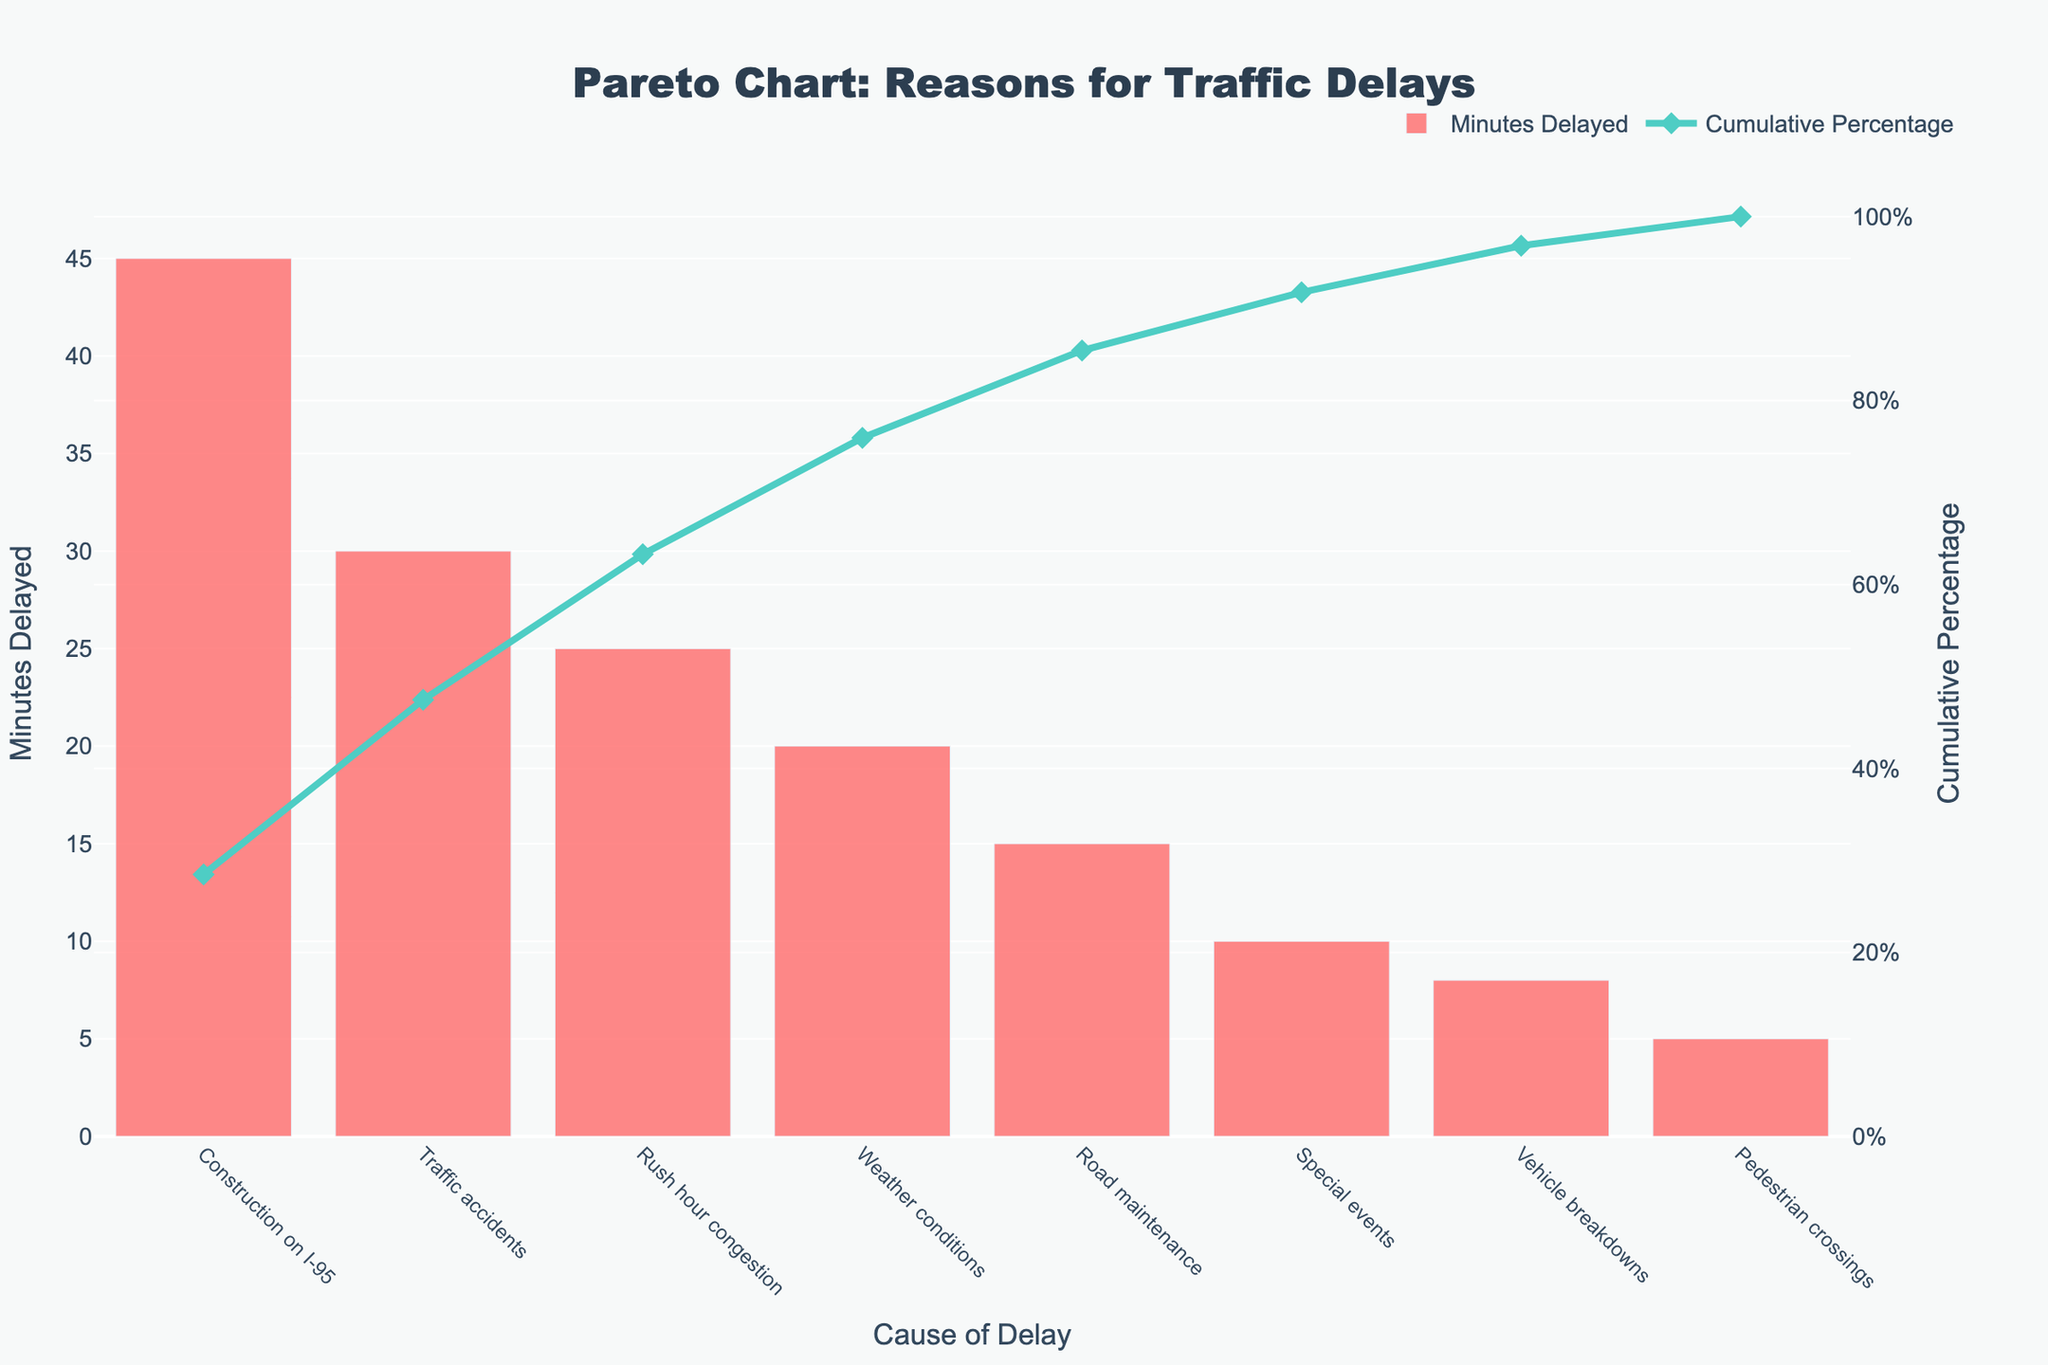what is the title of the chart? The title is mentioned at the top center of the chart.
Answer: Pareto Chart: Reasons for Traffic Delays how many causes for traffic delays are listed in the chart? There are distinct bars representing each cause on the x-axis. Count the bars.
Answer: 8 which cause contributes the most to traffic delays? The tallest bar represents the cause that delays traffic the most.
Answer: Construction on I-95 what is the cumulative percentage when including 'Weather conditions'? Look at the cumulative percentage line and check the value above the 'Weather conditions' x-coordinate.
Answer: 86.59% how many minutes are contributed by ‘Special events’ to traffic delays? Look at the height of the bar labeled ‘Special events’ on the x-axis.
Answer: 10 how does the contribution of 'Rush hour congestion' compare to 'Road maintenance'? Compare the heights of the bars for 'Rush hour congestion' and 'Road maintenance'.
Answer: Rush hour congestion contributes more (25 mins vs. 15 mins) what is the combined delay caused by 'Vehicle breakdowns' and 'Pedestrian crossings'? Add the heights of the bars for 'Vehicle breakdowns' and 'Pedestrian crossings'.
Answer: 13 minutes what percentage of total delay is accounted for by the two most impactful causes? Identify the cumulative percentage above the second tallest bar ('Traffic accidents') on the line chart.
Answer: 65.71% what is the incremental impact of 'Traffic accidents' following 'Construction on I-95'? Subtract the height of the bar for 'Construction on I-95' from the height of the bar for 'Traffic accidents'.
Answer: 15 minutes which three causes together account for more than half of the traffic delays? Trace the cumulative percentage line till it crosses 50% and list the corresponding causes.
Answer: Construction on I-95, Traffic accidents, Rush hour congestion 